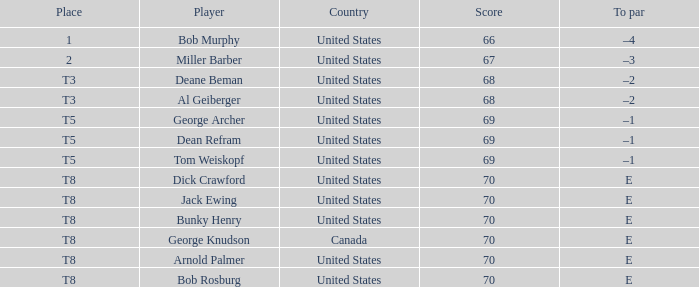When bunky henry secured t8, what was his to par? E. 